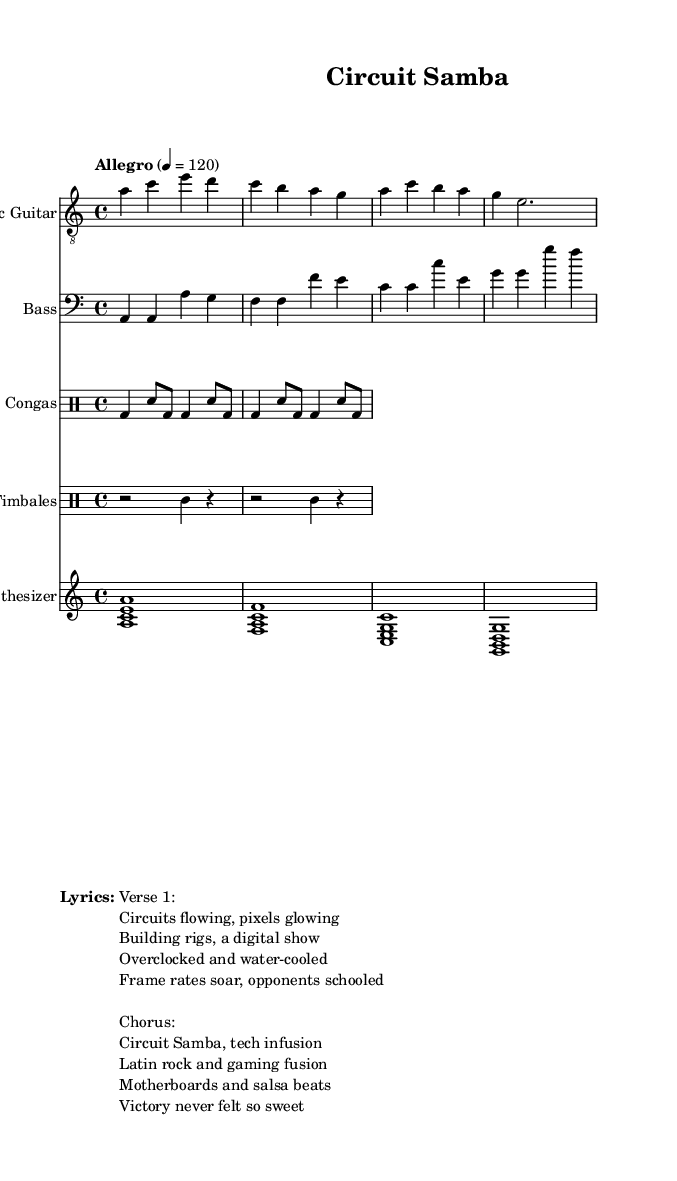What is the key signature of this music? The key signature is A minor, which has no sharps or flats.
Answer: A minor What is the time signature of the piece? The time signature is indicated as 4/4, which means there are four beats per measure.
Answer: 4/4 What is the tempo marking for this piece? The tempo marking is "Allegro", which indicates a brisk and lively pace. The specific speed is given as 120 beats per minute.
Answer: Allegro How many measures are in the electric guitar part? Counting the individual measures in the electric guitar notation, there are four measures present.
Answer: 4 Name one type of percussion instrument used in this composition. The composition includes congas as one of the percussion instruments.
Answer: Congas Describe the thematic content reflected in the lyrics. The lyrics mention technological elements like "circuits," "overclocked," and "motherboards," indicating a fusion of gaming and Latin music themes.
Answer: Technology Which section of the lyrics is labeled as the chorus? The section starting with "Circuit Samba, tech infusion" is labeled as the chorus, making it a prominent and repeating segment.
Answer: Chorus 